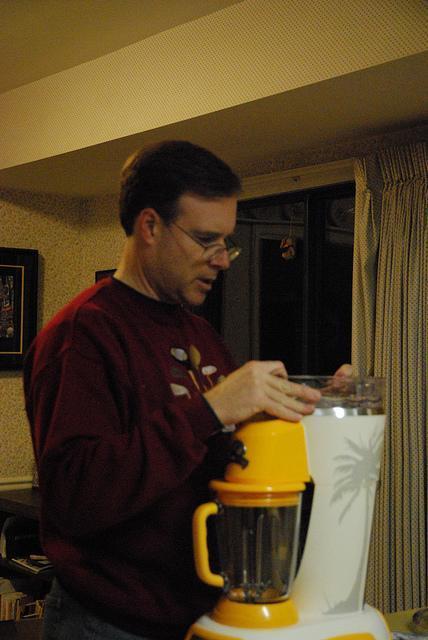How many people?
Give a very brief answer. 1. 